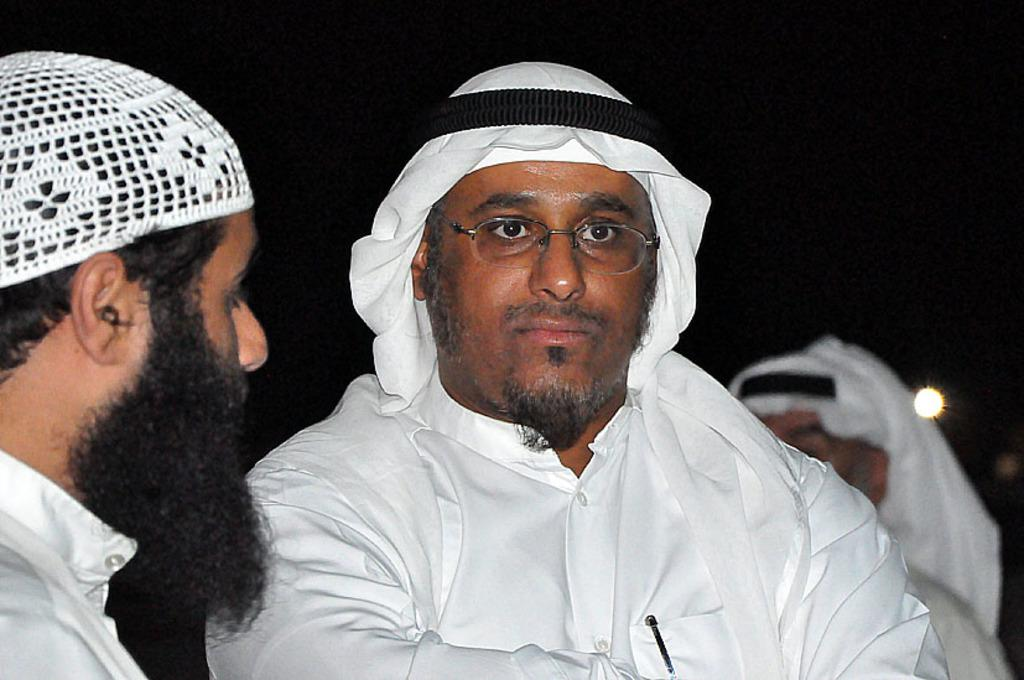What is located in the foreground of the image? There are people in the foreground of the image. Can you describe the person in the background of the image? There is a person in the background of the image. What can be seen in the background of the image? There is light visible in the background of the image. What type of yoke is being used by the person in the image? There is no yoke present in the image. What need is the person in the image trying to fulfill? The image does not provide enough information to determine the person's need or purpose. Can you tell me how many tigers are visible in the image? There are no tigers present in the image. 